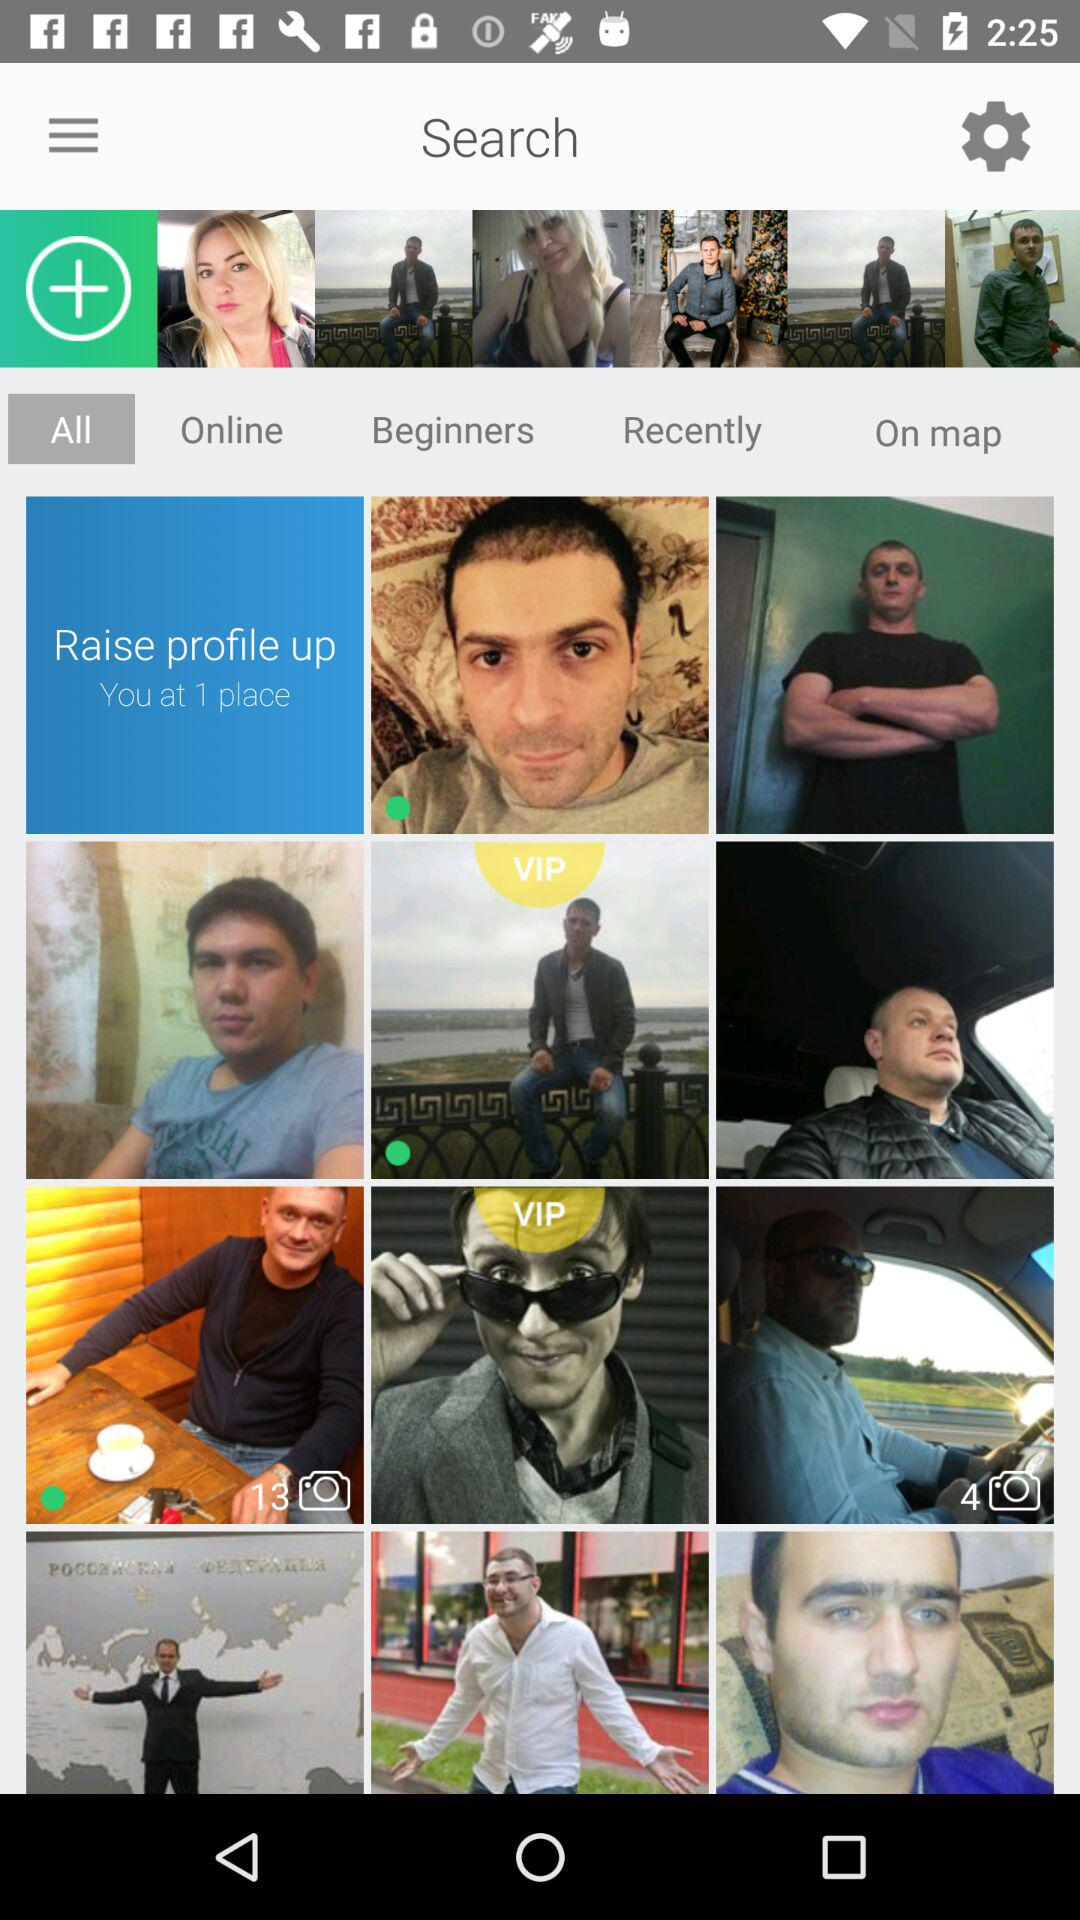Which tab has been selected? The selected tab is "All". 